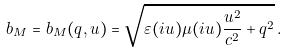Convert formula to latex. <formula><loc_0><loc_0><loc_500><loc_500>b _ { M } = b _ { M } ( q , u ) = \sqrt { \varepsilon ( i u ) \mu ( i u ) \frac { u ^ { 2 } } { c ^ { 2 } } + q ^ { 2 } } \, .</formula> 